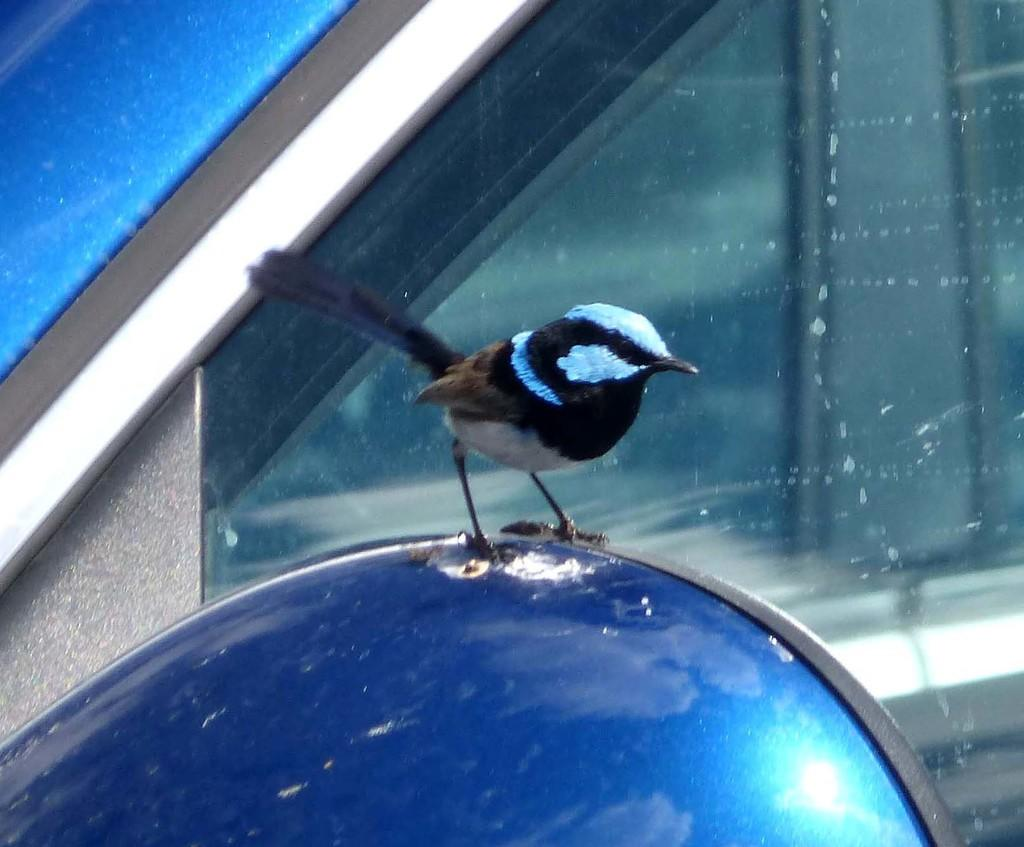What is the main subject of the image? The main subject of the image is a car. Can you describe the color of the car? The car is blue. Are there any other objects or creatures present in the image? Yes, there is a bird on the car. What type of pencil can be seen in the image? There is no pencil present in the image. What kind of trouble is the bird causing on the car? The image does not show any trouble caused by the bird; it is simply perched on the car. 